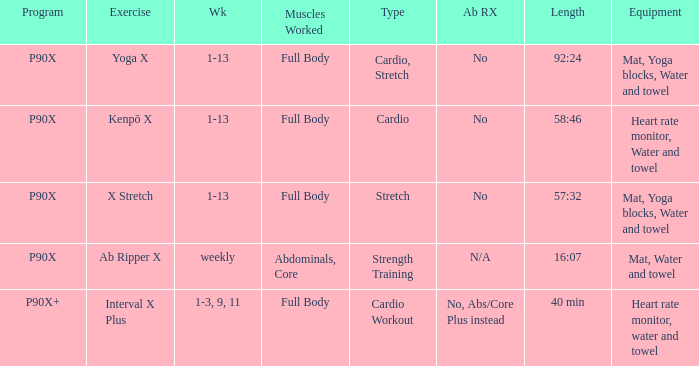What is the ab ripper x when exercise is x stretch? No. 